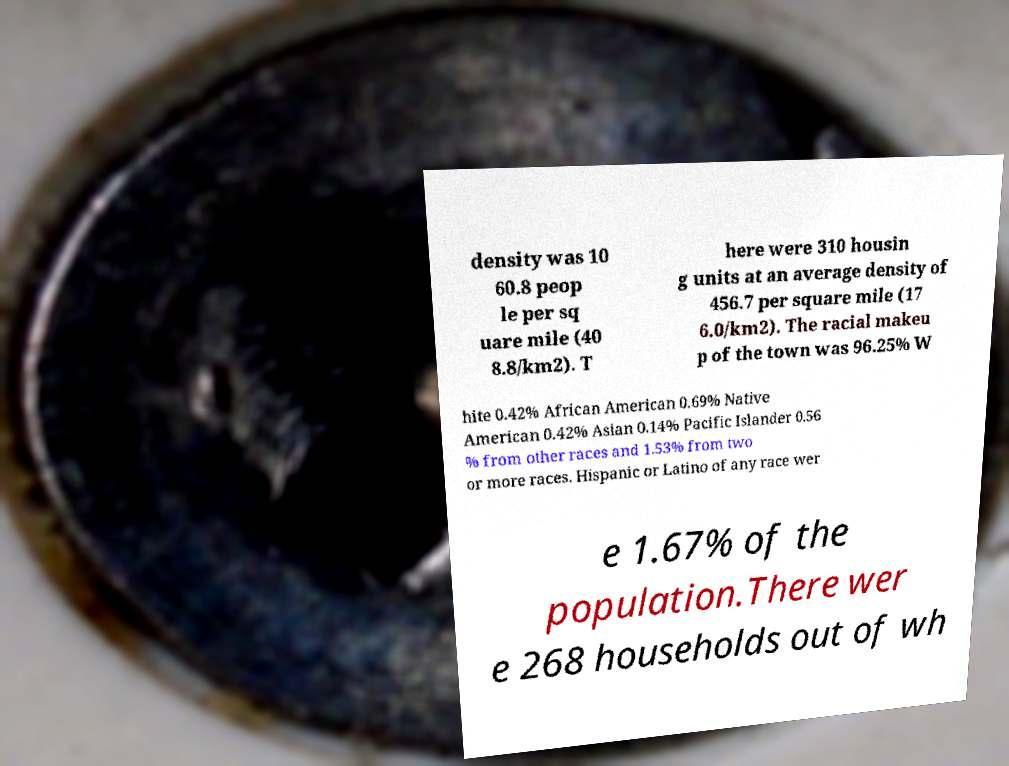For documentation purposes, I need the text within this image transcribed. Could you provide that? density was 10 60.8 peop le per sq uare mile (40 8.8/km2). T here were 310 housin g units at an average density of 456.7 per square mile (17 6.0/km2). The racial makeu p of the town was 96.25% W hite 0.42% African American 0.69% Native American 0.42% Asian 0.14% Pacific Islander 0.56 % from other races and 1.53% from two or more races. Hispanic or Latino of any race wer e 1.67% of the population.There wer e 268 households out of wh 